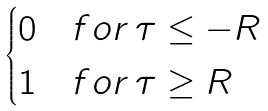<formula> <loc_0><loc_0><loc_500><loc_500>\begin{cases} 0 \quad f o r \, \tau \leq - R \\ 1 \quad f o r \, \tau \geq R \end{cases}</formula> 